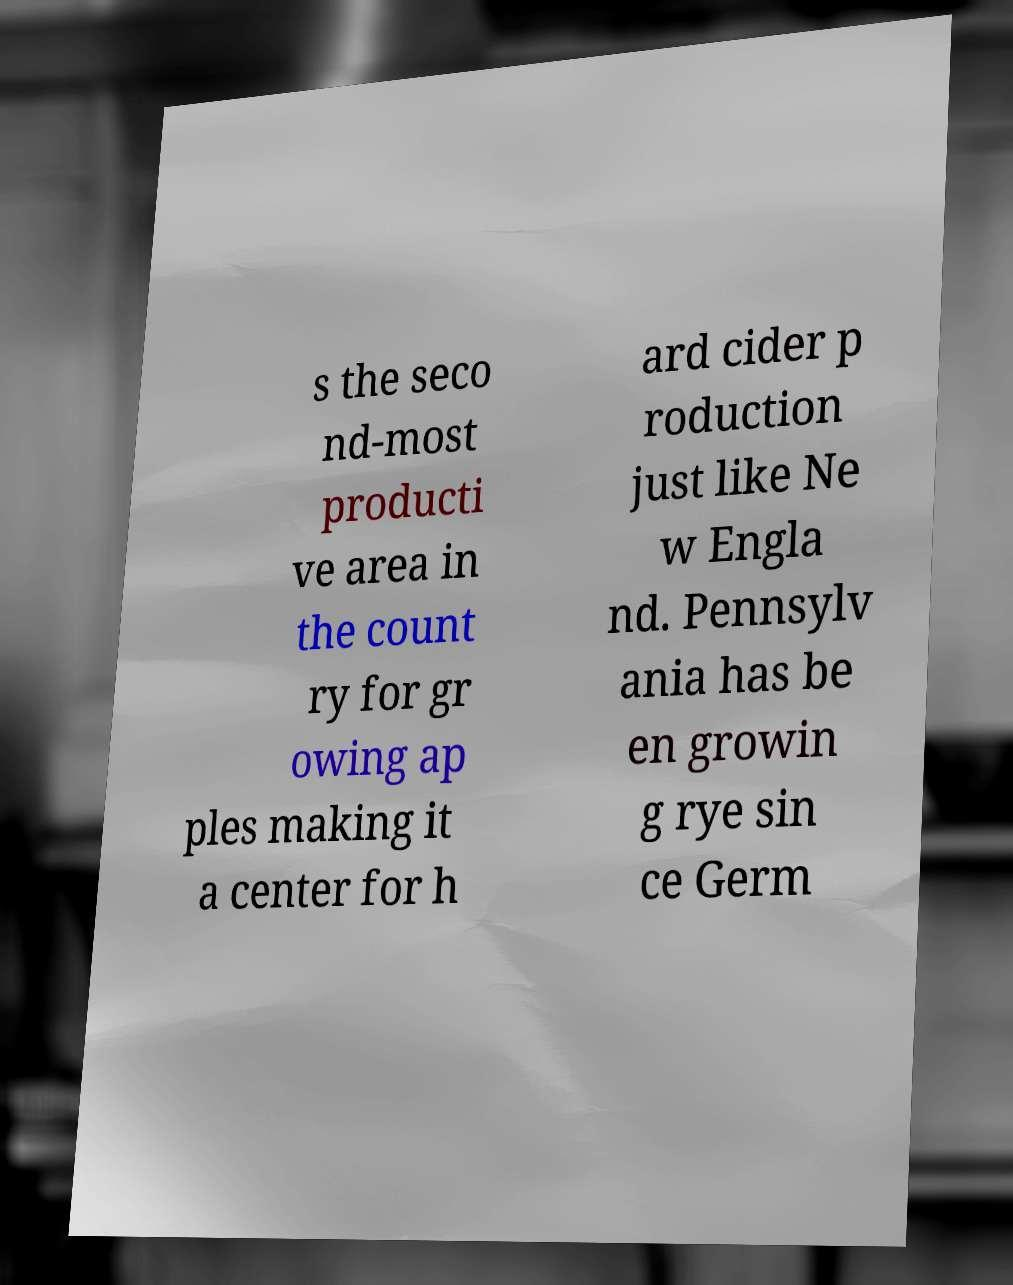Could you extract and type out the text from this image? s the seco nd-most producti ve area in the count ry for gr owing ap ples making it a center for h ard cider p roduction just like Ne w Engla nd. Pennsylv ania has be en growin g rye sin ce Germ 